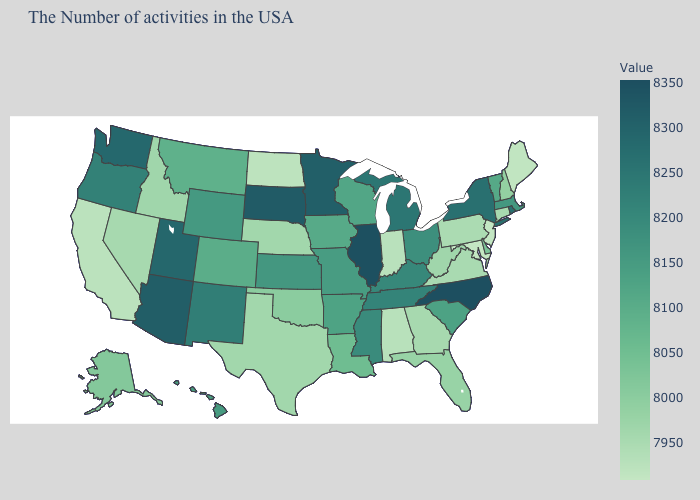Does the map have missing data?
Concise answer only. No. Does Maryland have the lowest value in the South?
Concise answer only. Yes. Among the states that border Colorado , which have the lowest value?
Quick response, please. Nebraska. 